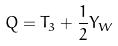Convert formula to latex. <formula><loc_0><loc_0><loc_500><loc_500>Q = T _ { 3 } + \frac { 1 } { 2 } Y _ { W }</formula> 